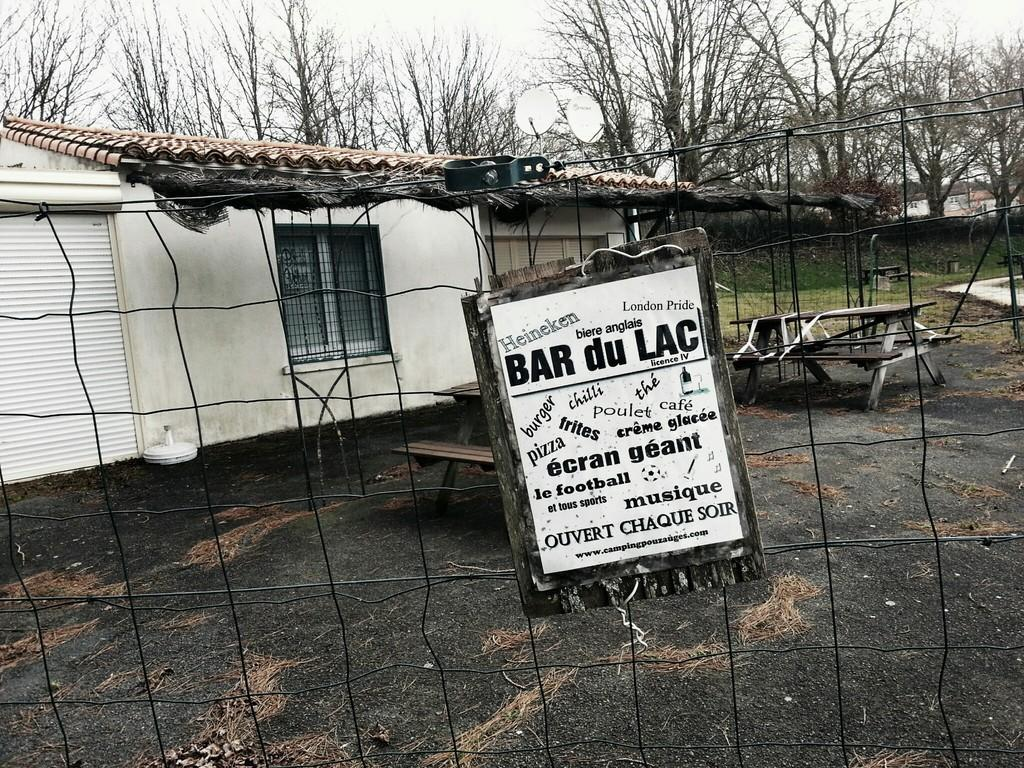<image>
Relay a brief, clear account of the picture shown. The sign is for the business called Bar du Lac 